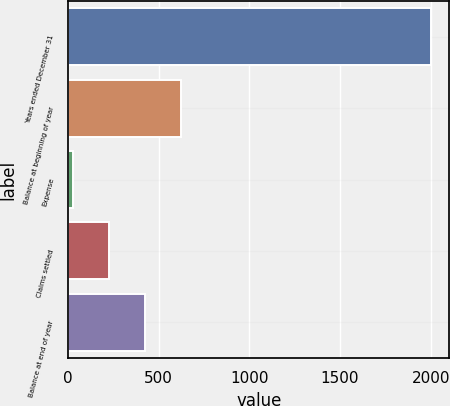Convert chart to OTSL. <chart><loc_0><loc_0><loc_500><loc_500><bar_chart><fcel>Years ended December 31<fcel>Balance at beginning of year<fcel>Expense<fcel>Claims settled<fcel>Balance at end of year<nl><fcel>2003<fcel>621.27<fcel>29.1<fcel>226.49<fcel>423.88<nl></chart> 